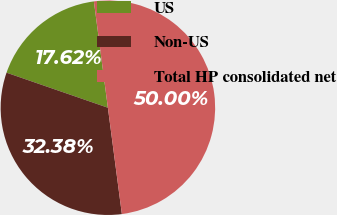<chart> <loc_0><loc_0><loc_500><loc_500><pie_chart><fcel>US<fcel>Non-US<fcel>Total HP consolidated net<nl><fcel>17.62%<fcel>32.38%<fcel>50.0%<nl></chart> 